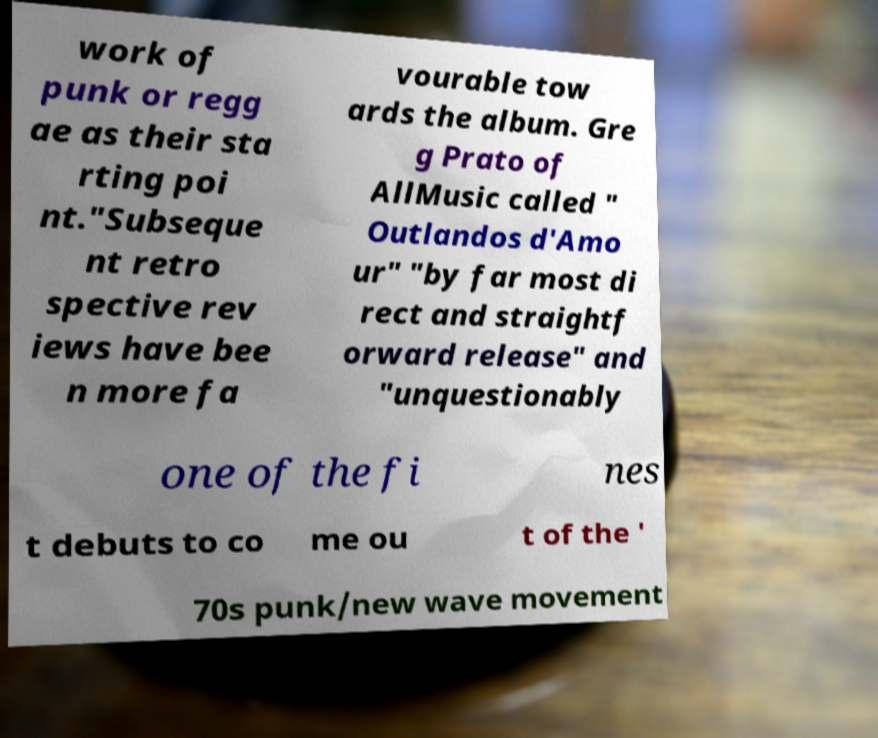Please read and relay the text visible in this image. What does it say? work of punk or regg ae as their sta rting poi nt."Subseque nt retro spective rev iews have bee n more fa vourable tow ards the album. Gre g Prato of AllMusic called " Outlandos d'Amo ur" "by far most di rect and straightf orward release" and "unquestionably one of the fi nes t debuts to co me ou t of the ' 70s punk/new wave movement 